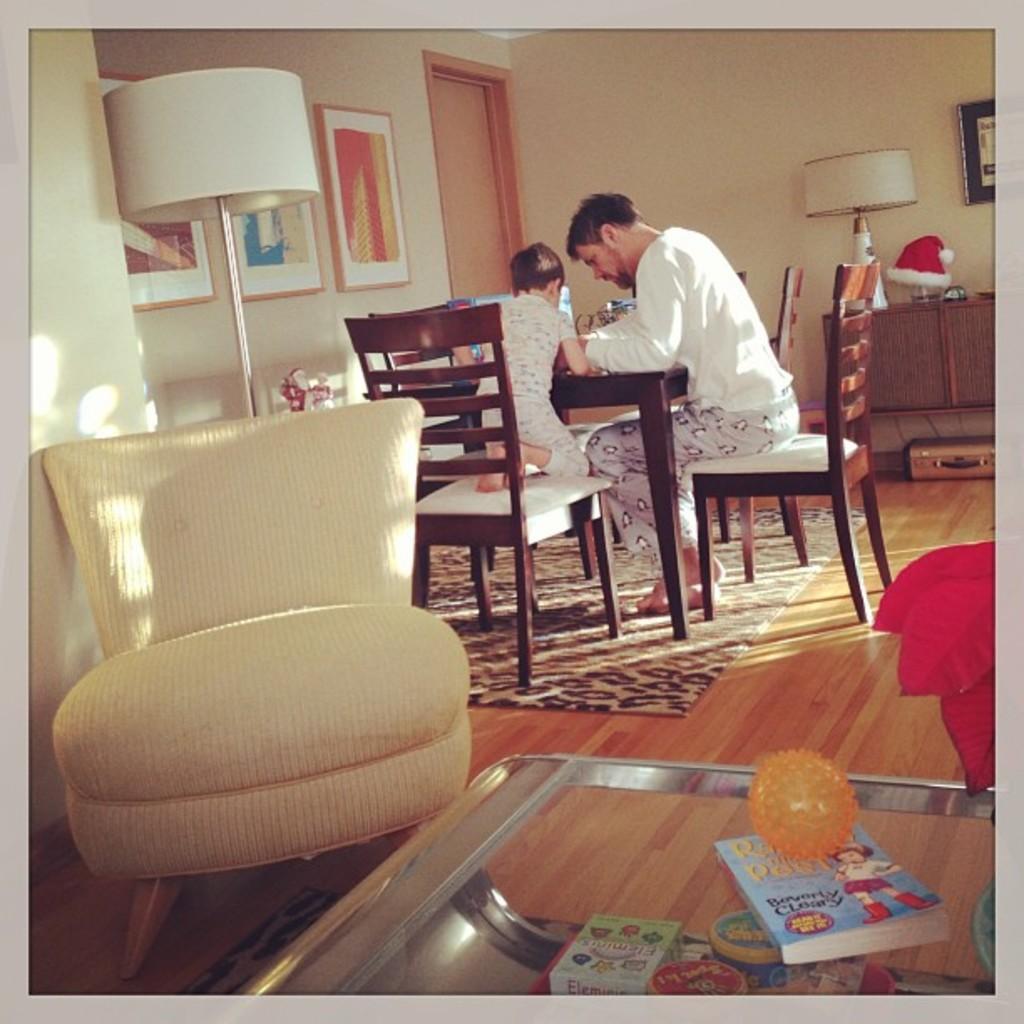Can you describe this image briefly? In this image in the middle there is a man he is sitting on the chair in front of that there is a table ,child, table and chairs. On the left there is a chair, lamp, photo frame,wall and door. At the bottom there is a book and floor. 